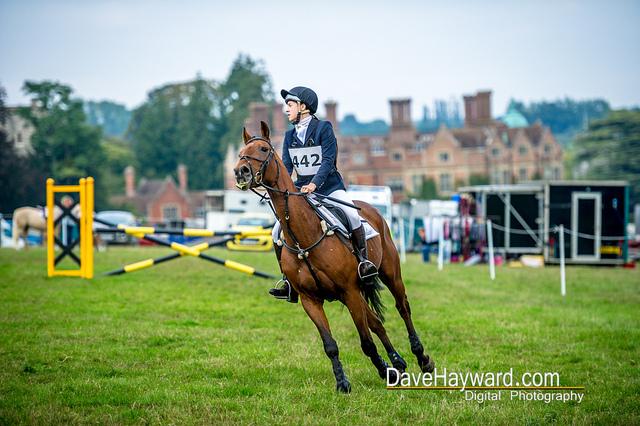Is this a horse tournament?
Give a very brief answer. Yes. How many wheels are in the photo?
Be succinct. 0. Did the horse knock down any of the jump poles?
Be succinct. No. What is the jokey's number?
Be succinct. 442. What does it appear that the rider has on the top of his helmet?
Quick response, please. Brim. What color are the jumping bars?
Give a very brief answer. Yellow and black. 